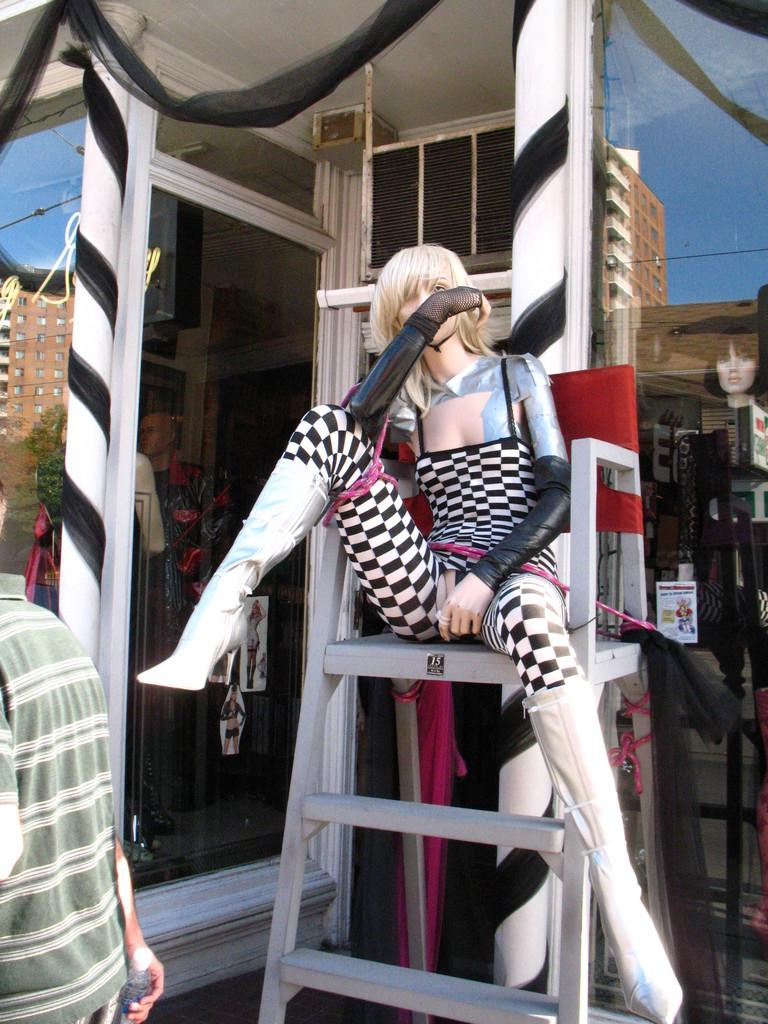What type of establishment is depicted in the image? There is a store in the image. What can be seen inside the store? There are mannequins in the image. What piece of furniture is present in the store? There is a chair in the image. What is unique about the store's walls? The store has glass walls. How can one enter or exit the store? There is a door in the image. Who is present in the image? There is a person in the image. What can be observed on the glass walls? There are reflections on the glass walls. What type of activity are the dogs participating in at the church in the image? There are no dogs or church present in the image. 